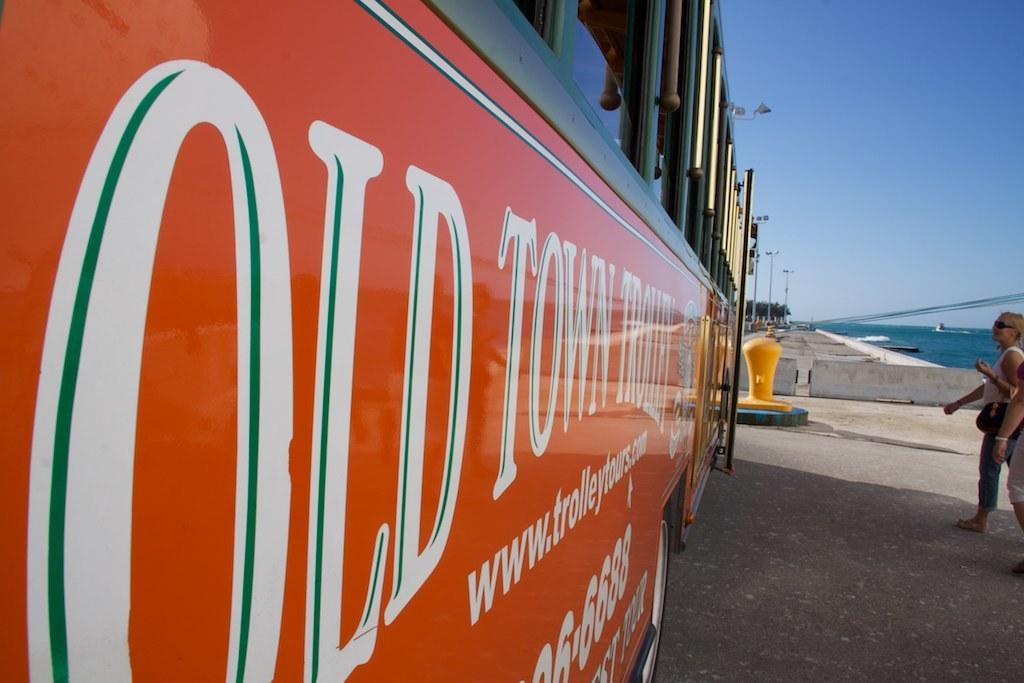<image>
Offer a succinct explanation of the picture presented. An orange bus has old town on the side. 